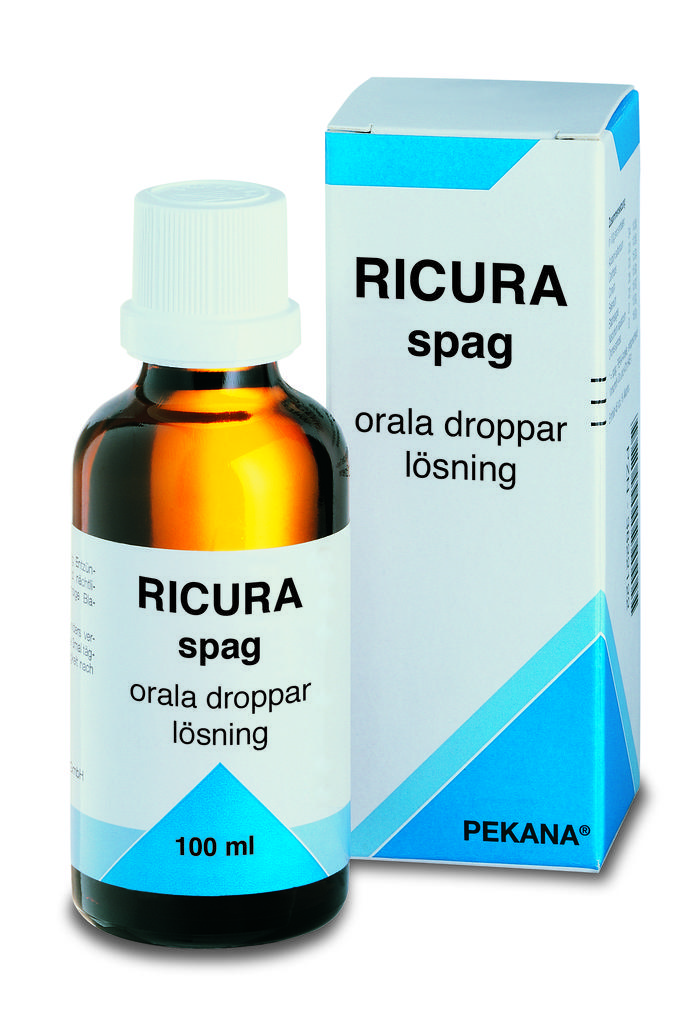What is the main subject of the image? The main subject of the image is a tonic. What color is the background of the tonic? The background of the tonic is white. What type of ticket is visible in the image? There is no ticket present in the image; it only contains a tonic with a white background. What time of day is depicted in the image? The image does not depict a specific time of day, as it only contains a tonic with a white background. 